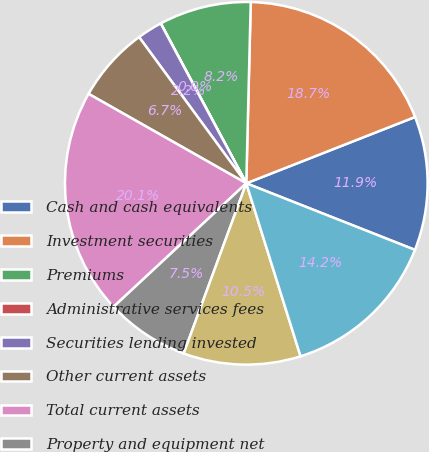<chart> <loc_0><loc_0><loc_500><loc_500><pie_chart><fcel>Cash and cash equivalents<fcel>Investment securities<fcel>Premiums<fcel>Administrative services fees<fcel>Securities lending invested<fcel>Other current assets<fcel>Total current assets<fcel>Property and equipment net<fcel>Long-term investment<fcel>Goodwill<nl><fcel>11.94%<fcel>18.65%<fcel>8.21%<fcel>0.01%<fcel>2.24%<fcel>6.72%<fcel>20.14%<fcel>7.46%<fcel>10.45%<fcel>14.18%<nl></chart> 